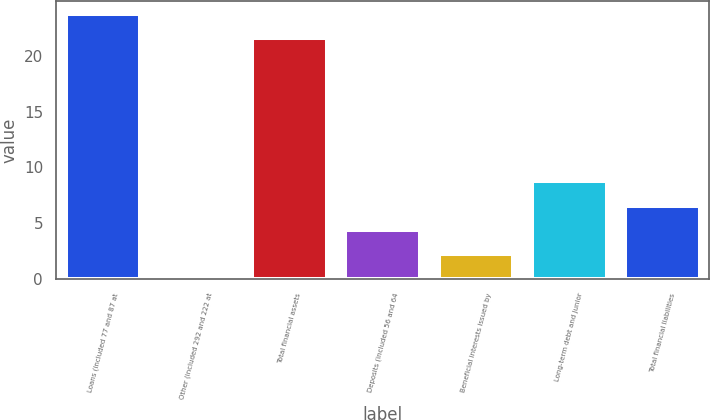<chart> <loc_0><loc_0><loc_500><loc_500><bar_chart><fcel>Loans (included 77 and 87 at<fcel>Other (included 292 and 222 at<fcel>Total financial assets<fcel>Deposits (included 56 and 64<fcel>Beneficial interests issued by<fcel>Long-term debt and junior<fcel>Total financial liabilities<nl><fcel>23.76<fcel>0.1<fcel>21.6<fcel>4.42<fcel>2.26<fcel>8.74<fcel>6.58<nl></chart> 